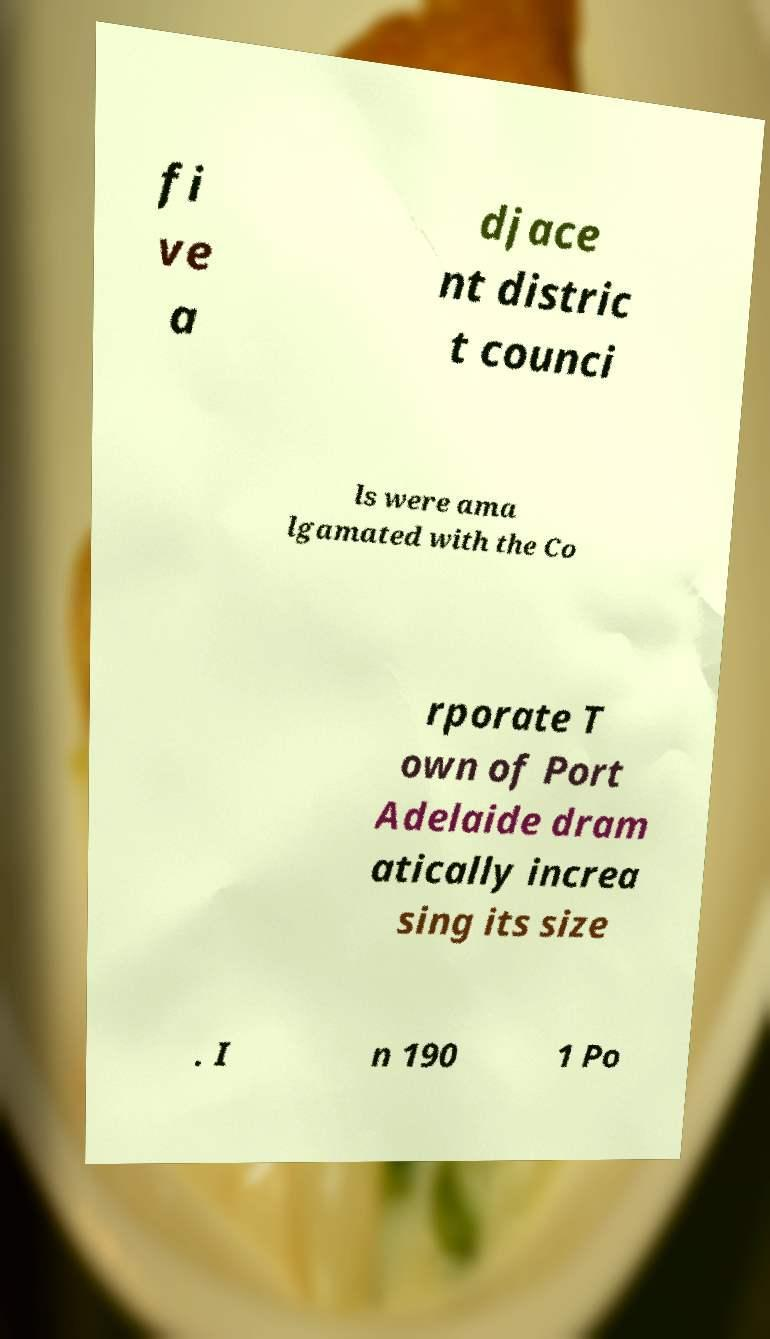Can you accurately transcribe the text from the provided image for me? fi ve a djace nt distric t counci ls were ama lgamated with the Co rporate T own of Port Adelaide dram atically increa sing its size . I n 190 1 Po 